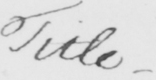What is written in this line of handwriting? Title . 